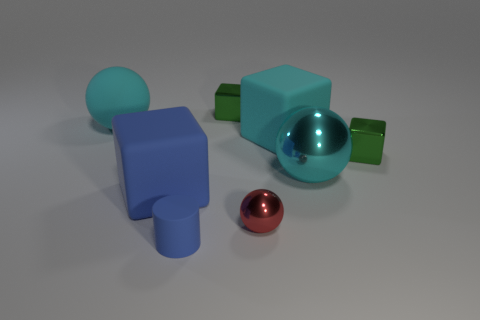Add 2 large blue objects. How many objects exist? 10 Subtract all spheres. How many objects are left? 5 Add 7 big balls. How many big balls exist? 9 Subtract 0 yellow blocks. How many objects are left? 8 Subtract all tiny cyan metallic balls. Subtract all big blue things. How many objects are left? 7 Add 8 metallic spheres. How many metallic spheres are left? 10 